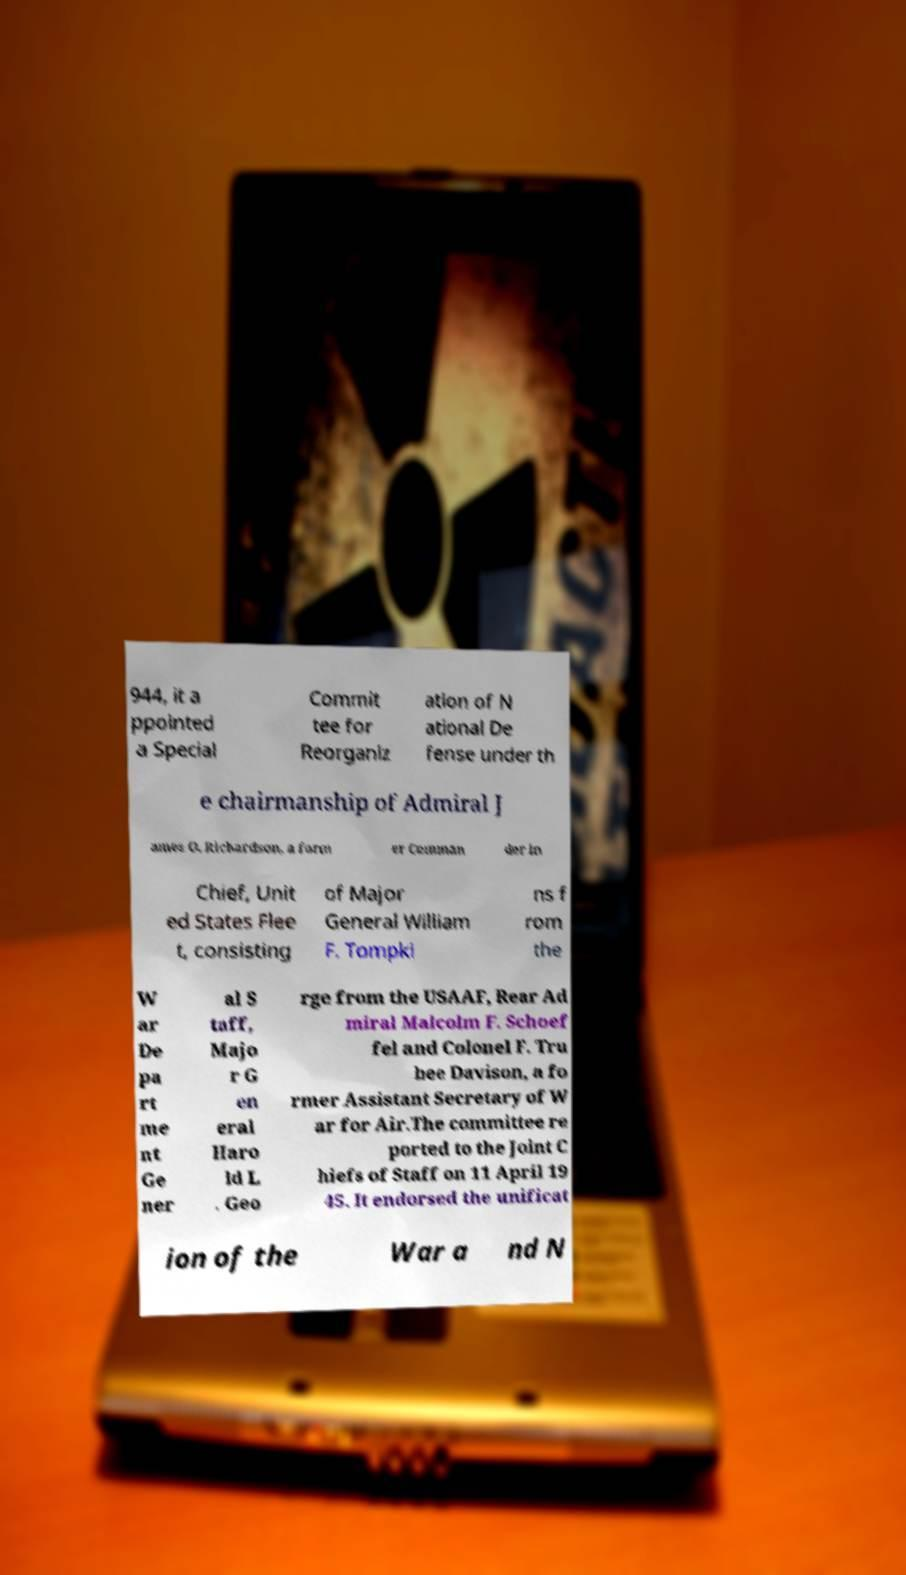Could you extract and type out the text from this image? 944, it a ppointed a Special Commit tee for Reorganiz ation of N ational De fense under th e chairmanship of Admiral J ames O. Richardson, a form er Comman der in Chief, Unit ed States Flee t, consisting of Major General William F. Tompki ns f rom the W ar De pa rt me nt Ge ner al S taff, Majo r G en eral Haro ld L . Geo rge from the USAAF, Rear Ad miral Malcolm F. Schoef fel and Colonel F. Tru bee Davison, a fo rmer Assistant Secretary of W ar for Air.The committee re ported to the Joint C hiefs of Staff on 11 April 19 45. It endorsed the unificat ion of the War a nd N 